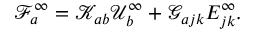<formula> <loc_0><loc_0><loc_500><loc_500>\mathcal { F } _ { a } ^ { \infty } = \mathcal { K } _ { a b } \mathcal { U } _ { b } ^ { \infty } + \mathcal { G } _ { a j k } E _ { j k } ^ { \infty } .</formula> 